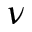<formula> <loc_0><loc_0><loc_500><loc_500>\nu</formula> 